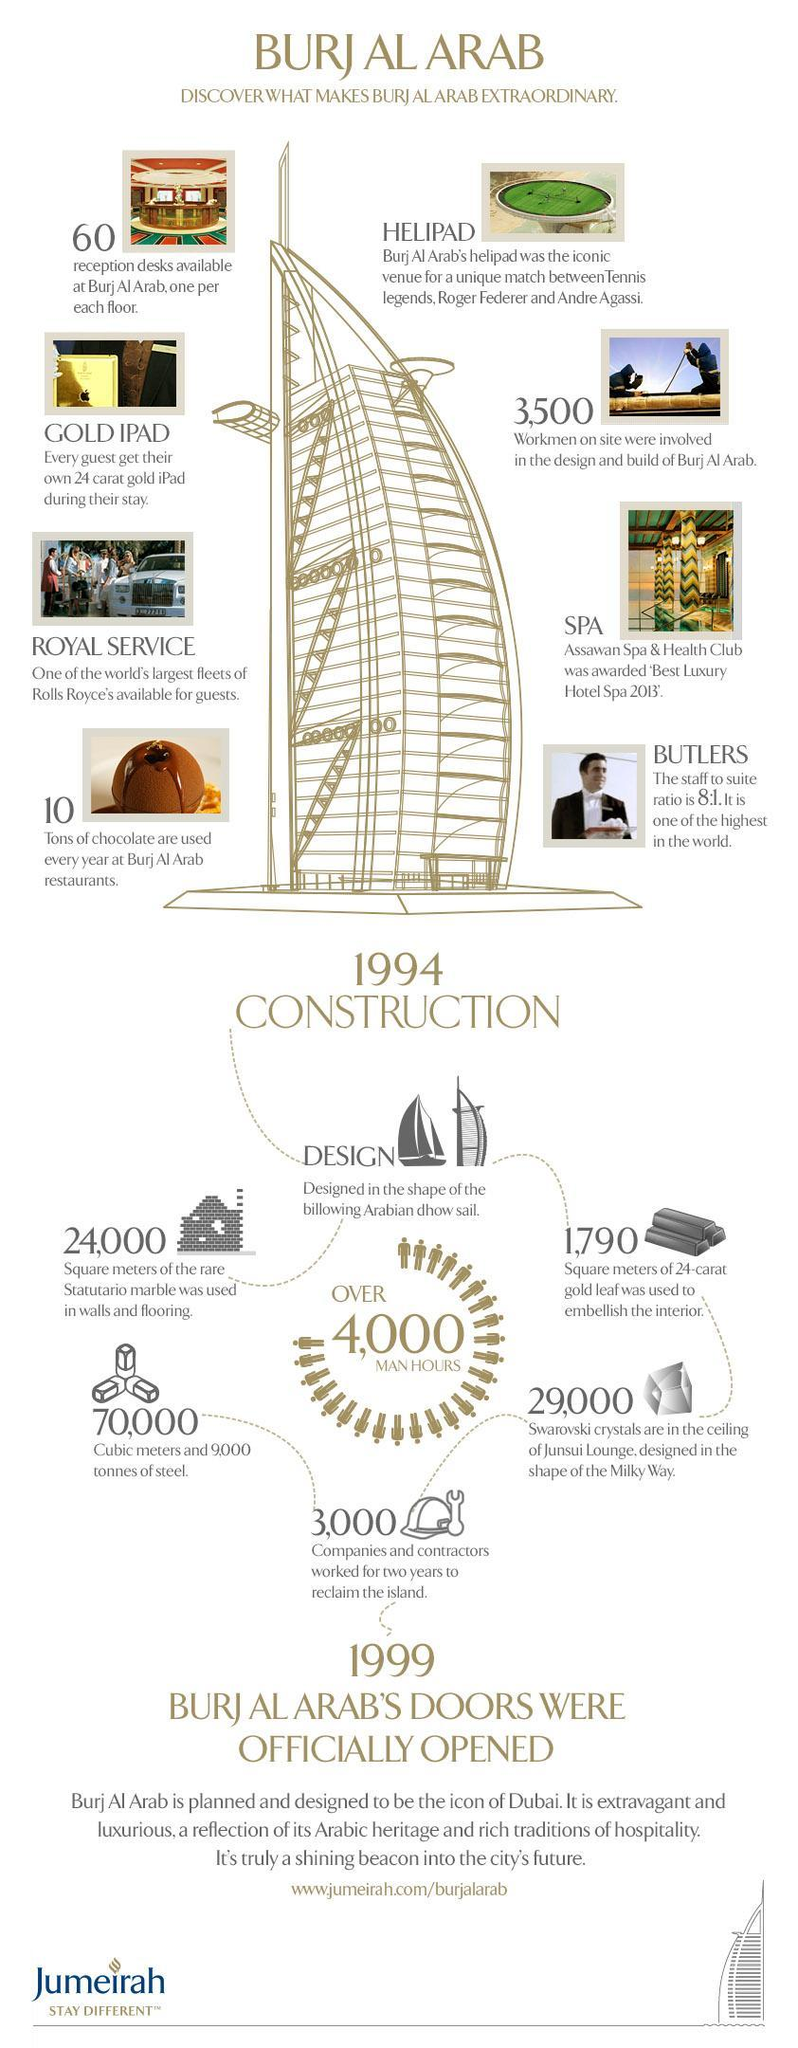How many workmen on site were involved in the design of Burj Al Arab?
Answer the question with a short phrase. 3,500 How many companies & contractors worked for two years to reclaim the island? 3,000 How many tons of chocolate are used every year at Burj Al Arab restaurants? 10 Tons When did the construction of Burj Al Arab started? 1994 How many swarovski crystals were used in the ceiling of Junsui Lounge designed in the shape of milky way? 29,000 How many man hours were dedicated inorder to build Burj Al Arab? over 4000 How many reception desks are available at Burj Al Arab? 60 When was the construction of Burj Al Arab completed? 1999 How many square meters of 24-carat gold leaf was used to embellish the interior of Burj Al Arab? 1,790 